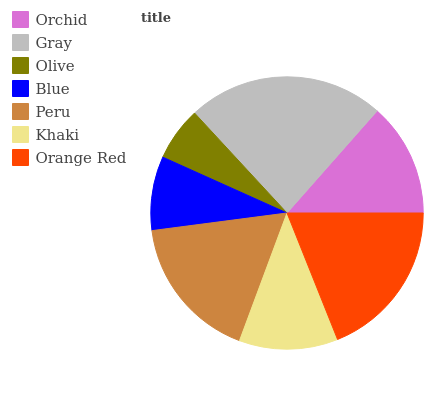Is Olive the minimum?
Answer yes or no. Yes. Is Gray the maximum?
Answer yes or no. Yes. Is Gray the minimum?
Answer yes or no. No. Is Olive the maximum?
Answer yes or no. No. Is Gray greater than Olive?
Answer yes or no. Yes. Is Olive less than Gray?
Answer yes or no. Yes. Is Olive greater than Gray?
Answer yes or no. No. Is Gray less than Olive?
Answer yes or no. No. Is Orchid the high median?
Answer yes or no. Yes. Is Orchid the low median?
Answer yes or no. Yes. Is Olive the high median?
Answer yes or no. No. Is Gray the low median?
Answer yes or no. No. 